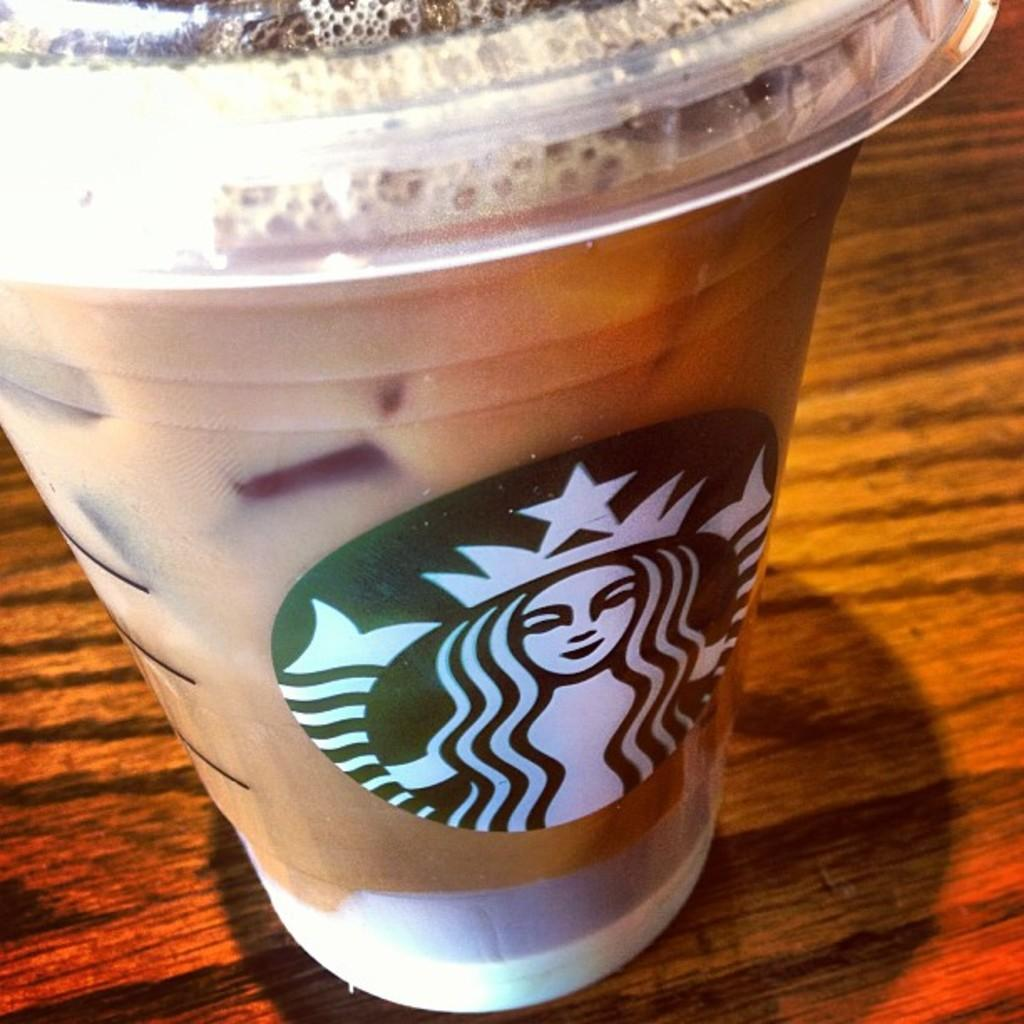What is in the coffee cup that is visible in the image? There is a coffee cup in the image. What brand is associated with the coffee cup? The coffee cup has a Starbucks symbol on it. Where is the coffee cup located in the image? The coffee cup is on a table. What type of hair can be seen on the bell in the image? There is no bell or hair present in the image. What station is the coffee cup associated with in the image? The image does not indicate any specific station associated with the coffee cup. 